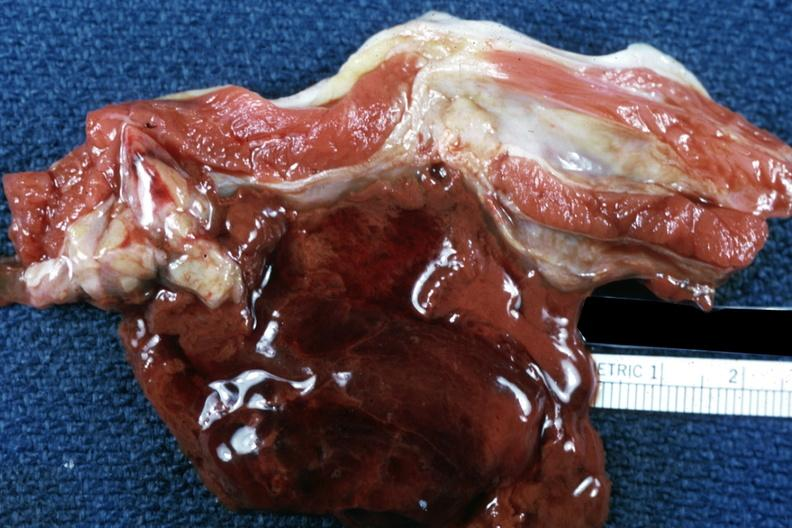s soft tissue present?
Answer the question using a single word or phrase. Yes 